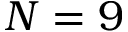<formula> <loc_0><loc_0><loc_500><loc_500>N = 9</formula> 